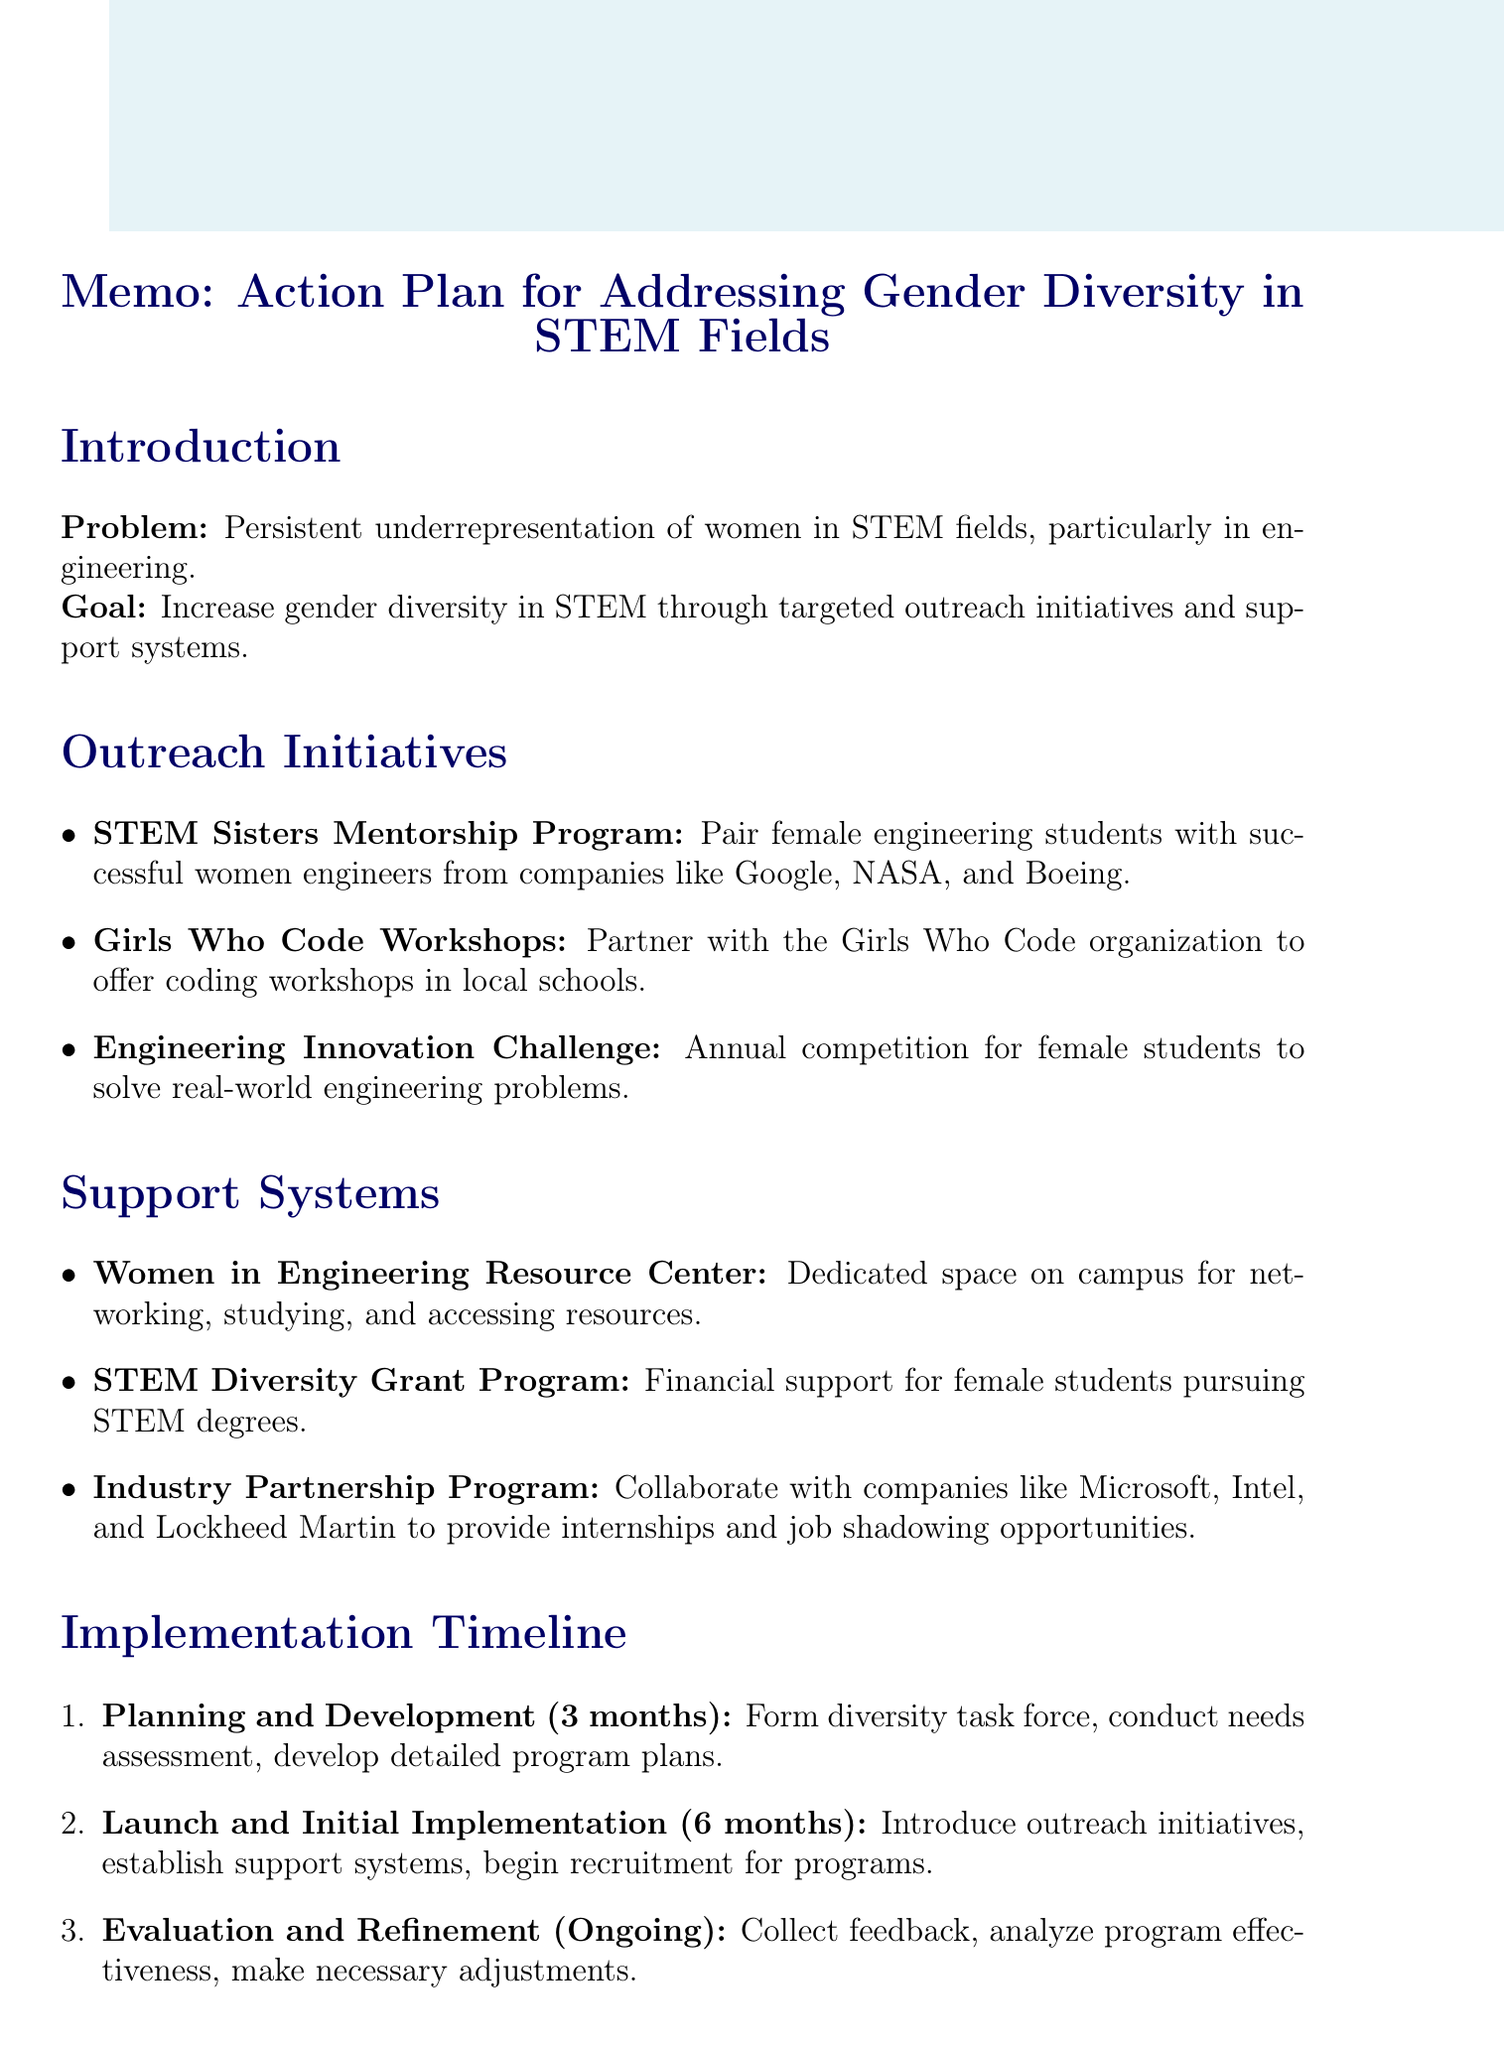What is the main goal of the action plan? The goal is to increase gender diversity in STEM through targeted outreach initiatives and support systems.
Answer: Increase gender diversity in STEM through targeted outreach initiatives and support systems How long is the planning and development phase? The document states that the duration for the planning and development phase is 3 months.
Answer: 3 months What is the name of the program that pairs female students with successful women engineers? The document mentions the STEM Sisters Mentorship Program, which pairs female engineering students with successful women engineers.
Answer: STEM Sisters Mentorship Program What financial support is offered through the STEM Diversity Grant Program? The document specifies that annual scholarships range from $5,000 to $20,000 for female students pursuing STEM degrees.
Answer: $5,000 to $20,000 Which companies are mentioned as partners in the Industry Partnership Program? The document lists companies like Microsoft, Intel, and Lockheed Martin as partners in the Industry Partnership Program.
Answer: Microsoft, Intel, and Lockheed Martin What are the key performance indicators used to measure effectiveness? The document outlines several key performance indicators, including the percentage increase in female enrollment in STEM programs.
Answer: Percentage increase in female enrollment in STEM programs What is the expected outcome of this action plan? The expected outcome is to increase the representation of women in engineering and other STEM fields.
Answer: Increased representation of women in engineering and other STEM fields 